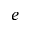<formula> <loc_0><loc_0><loc_500><loc_500>e</formula> 